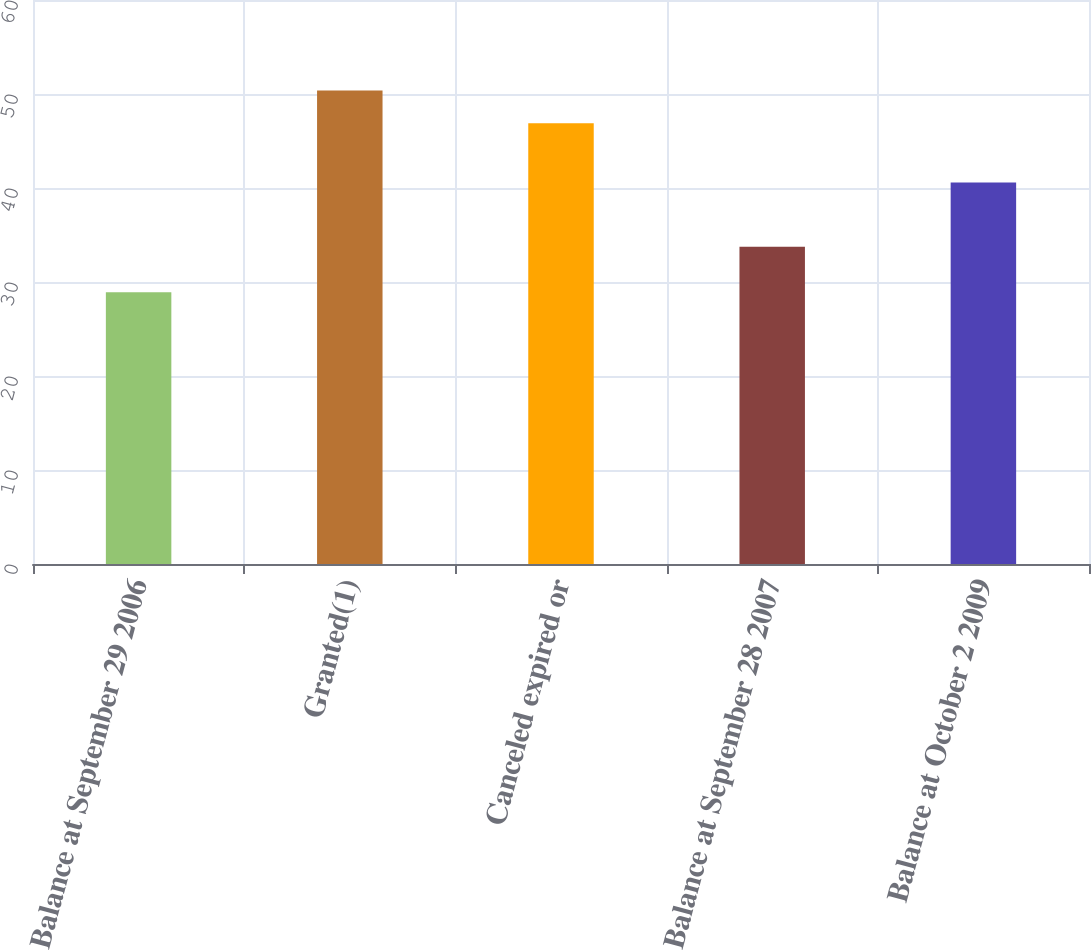<chart> <loc_0><loc_0><loc_500><loc_500><bar_chart><fcel>Balance at September 29 2006<fcel>Granted(1)<fcel>Canceled expired or<fcel>Balance at September 28 2007<fcel>Balance at October 2 2009<nl><fcel>28.9<fcel>50.38<fcel>46.89<fcel>33.75<fcel>40.59<nl></chart> 